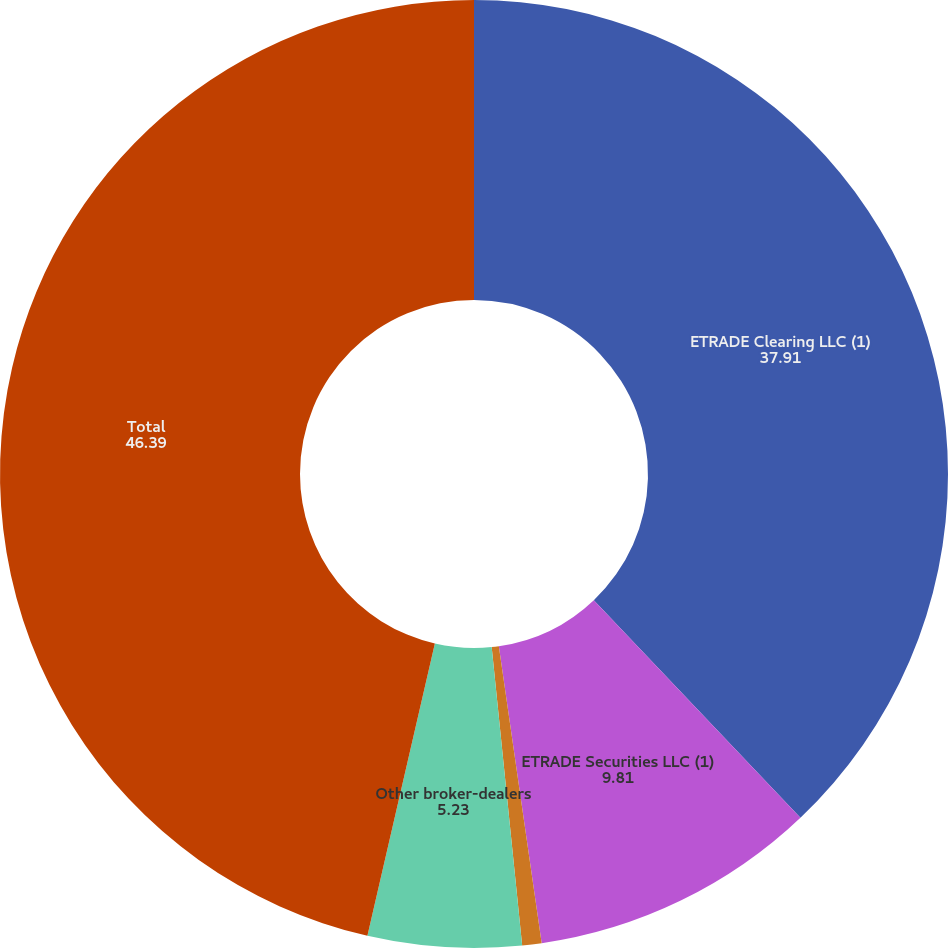<chart> <loc_0><loc_0><loc_500><loc_500><pie_chart><fcel>ETRADE Clearing LLC (1)<fcel>ETRADE Securities LLC (1)<fcel>G1 Execution Services LLC (2)<fcel>Other broker-dealers<fcel>Total<nl><fcel>37.91%<fcel>9.81%<fcel>0.66%<fcel>5.23%<fcel>46.39%<nl></chart> 